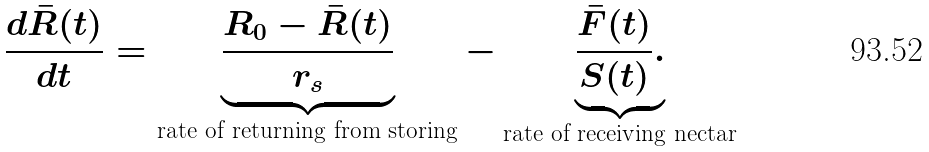<formula> <loc_0><loc_0><loc_500><loc_500>\frac { d \bar { R } ( t ) } { d t } = \underbrace { \frac { R _ { 0 } - \bar { R } ( t ) } { r _ { s } } } _ { \text {rate of returning from storing} } - \underbrace { \frac { \bar { F } ( t ) } { S ( t ) } . } _ { \text {rate of receiving nectar} }</formula> 